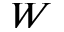Convert formula to latex. <formula><loc_0><loc_0><loc_500><loc_500>W</formula> 